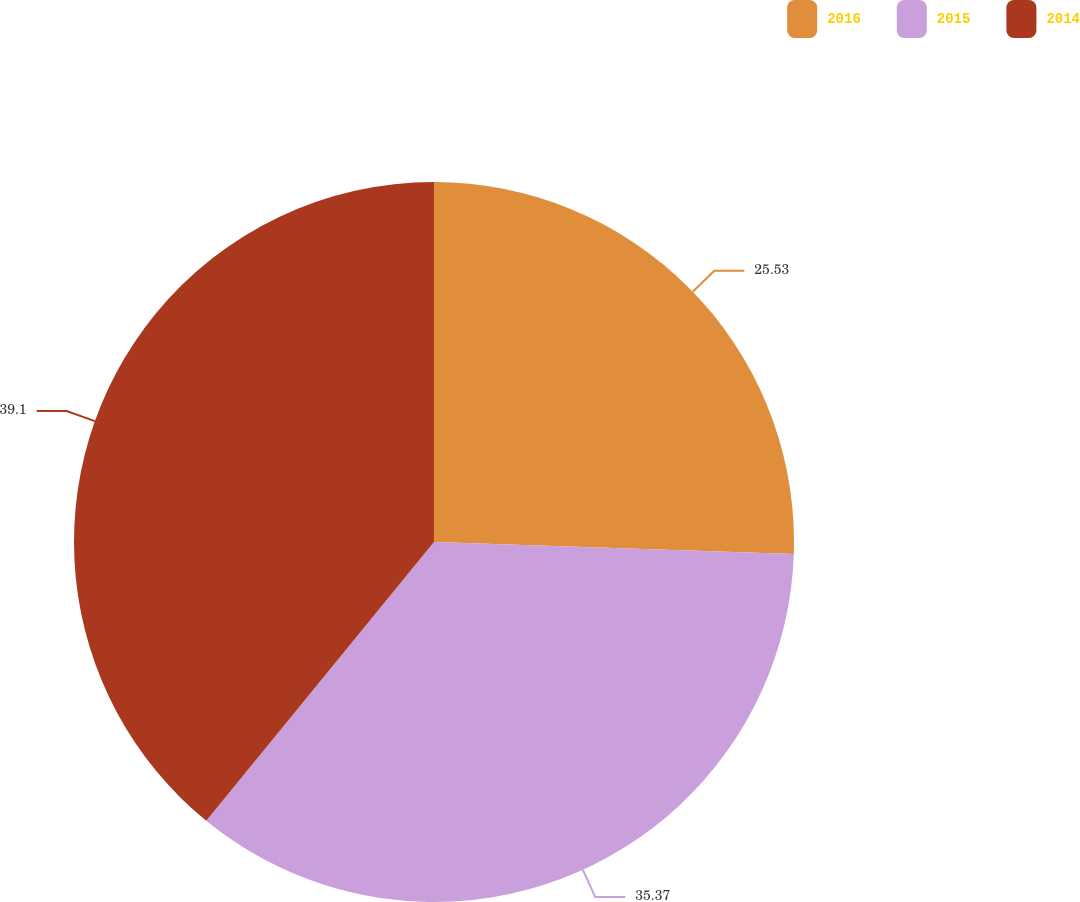Convert chart to OTSL. <chart><loc_0><loc_0><loc_500><loc_500><pie_chart><fcel>2016<fcel>2015<fcel>2014<nl><fcel>25.53%<fcel>35.37%<fcel>39.1%<nl></chart> 